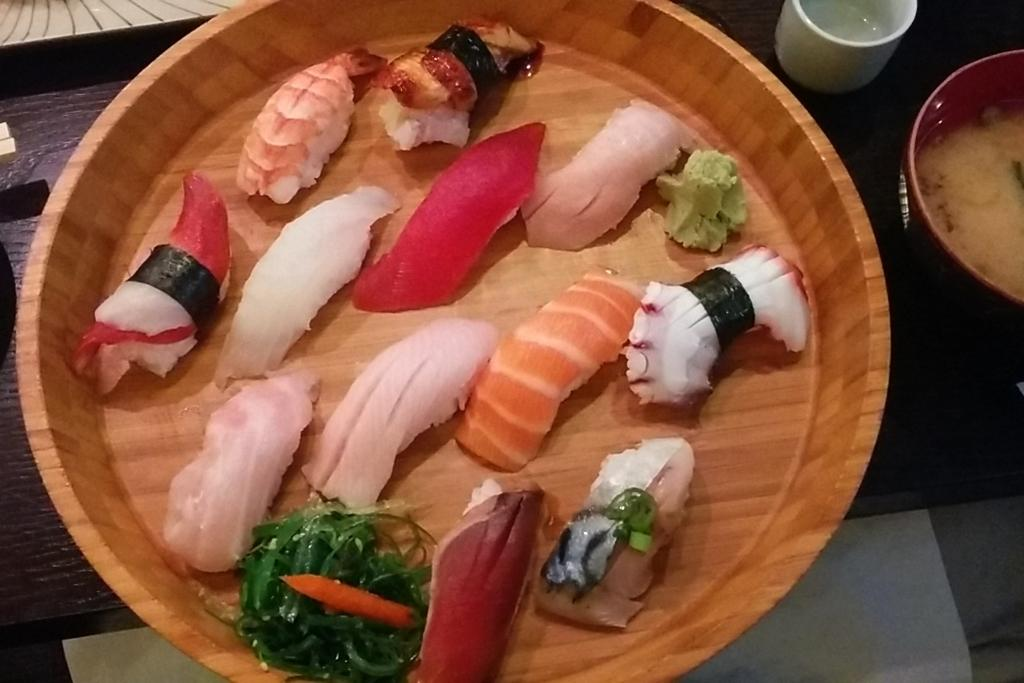What type of container is holding the eatable things in the image? There is a wooden bowl holding the eatable things in the image. Where is the wooden bowl located in the image? The wooden bowl is on the right side of the image. What other item is on the right side of the image? There is a cup on the right side of the image. On what surface are the bowl and cup placed? The items are placed on a surface. How does the wooden bowl cast a shadow in the image? The wooden bowl does not cast a shadow in the image, as there is no mention of light sources or shadows in the provided facts. 